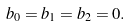<formula> <loc_0><loc_0><loc_500><loc_500>b _ { 0 } = b _ { 1 } = b _ { 2 } = 0 .</formula> 